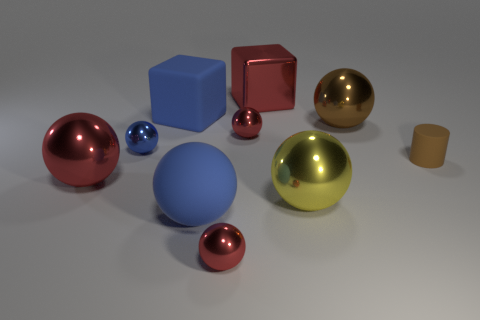What is the size of the yellow object?
Your answer should be compact. Large. How many things are either large balls or big metal balls that are left of the small blue metal object?
Your answer should be compact. 4. How many other objects are there of the same color as the large rubber cube?
Your answer should be very brief. 2. There is a brown cylinder; is it the same size as the shiny thing in front of the yellow metal ball?
Provide a short and direct response. Yes. Does the cube that is in front of the red block have the same size as the tiny cylinder?
Provide a short and direct response. No. How many other objects are the same material as the big brown object?
Your answer should be very brief. 6. Are there an equal number of brown rubber objects that are right of the brown metal thing and blue rubber blocks to the left of the cylinder?
Provide a short and direct response. Yes. There is a tiny thing that is in front of the rubber object that is on the right side of the large red shiny thing that is behind the matte cylinder; what is its color?
Give a very brief answer. Red. The metallic object that is on the right side of the big yellow metal ball has what shape?
Keep it short and to the point. Sphere. There is a big brown object that is made of the same material as the big yellow object; what shape is it?
Provide a short and direct response. Sphere. 